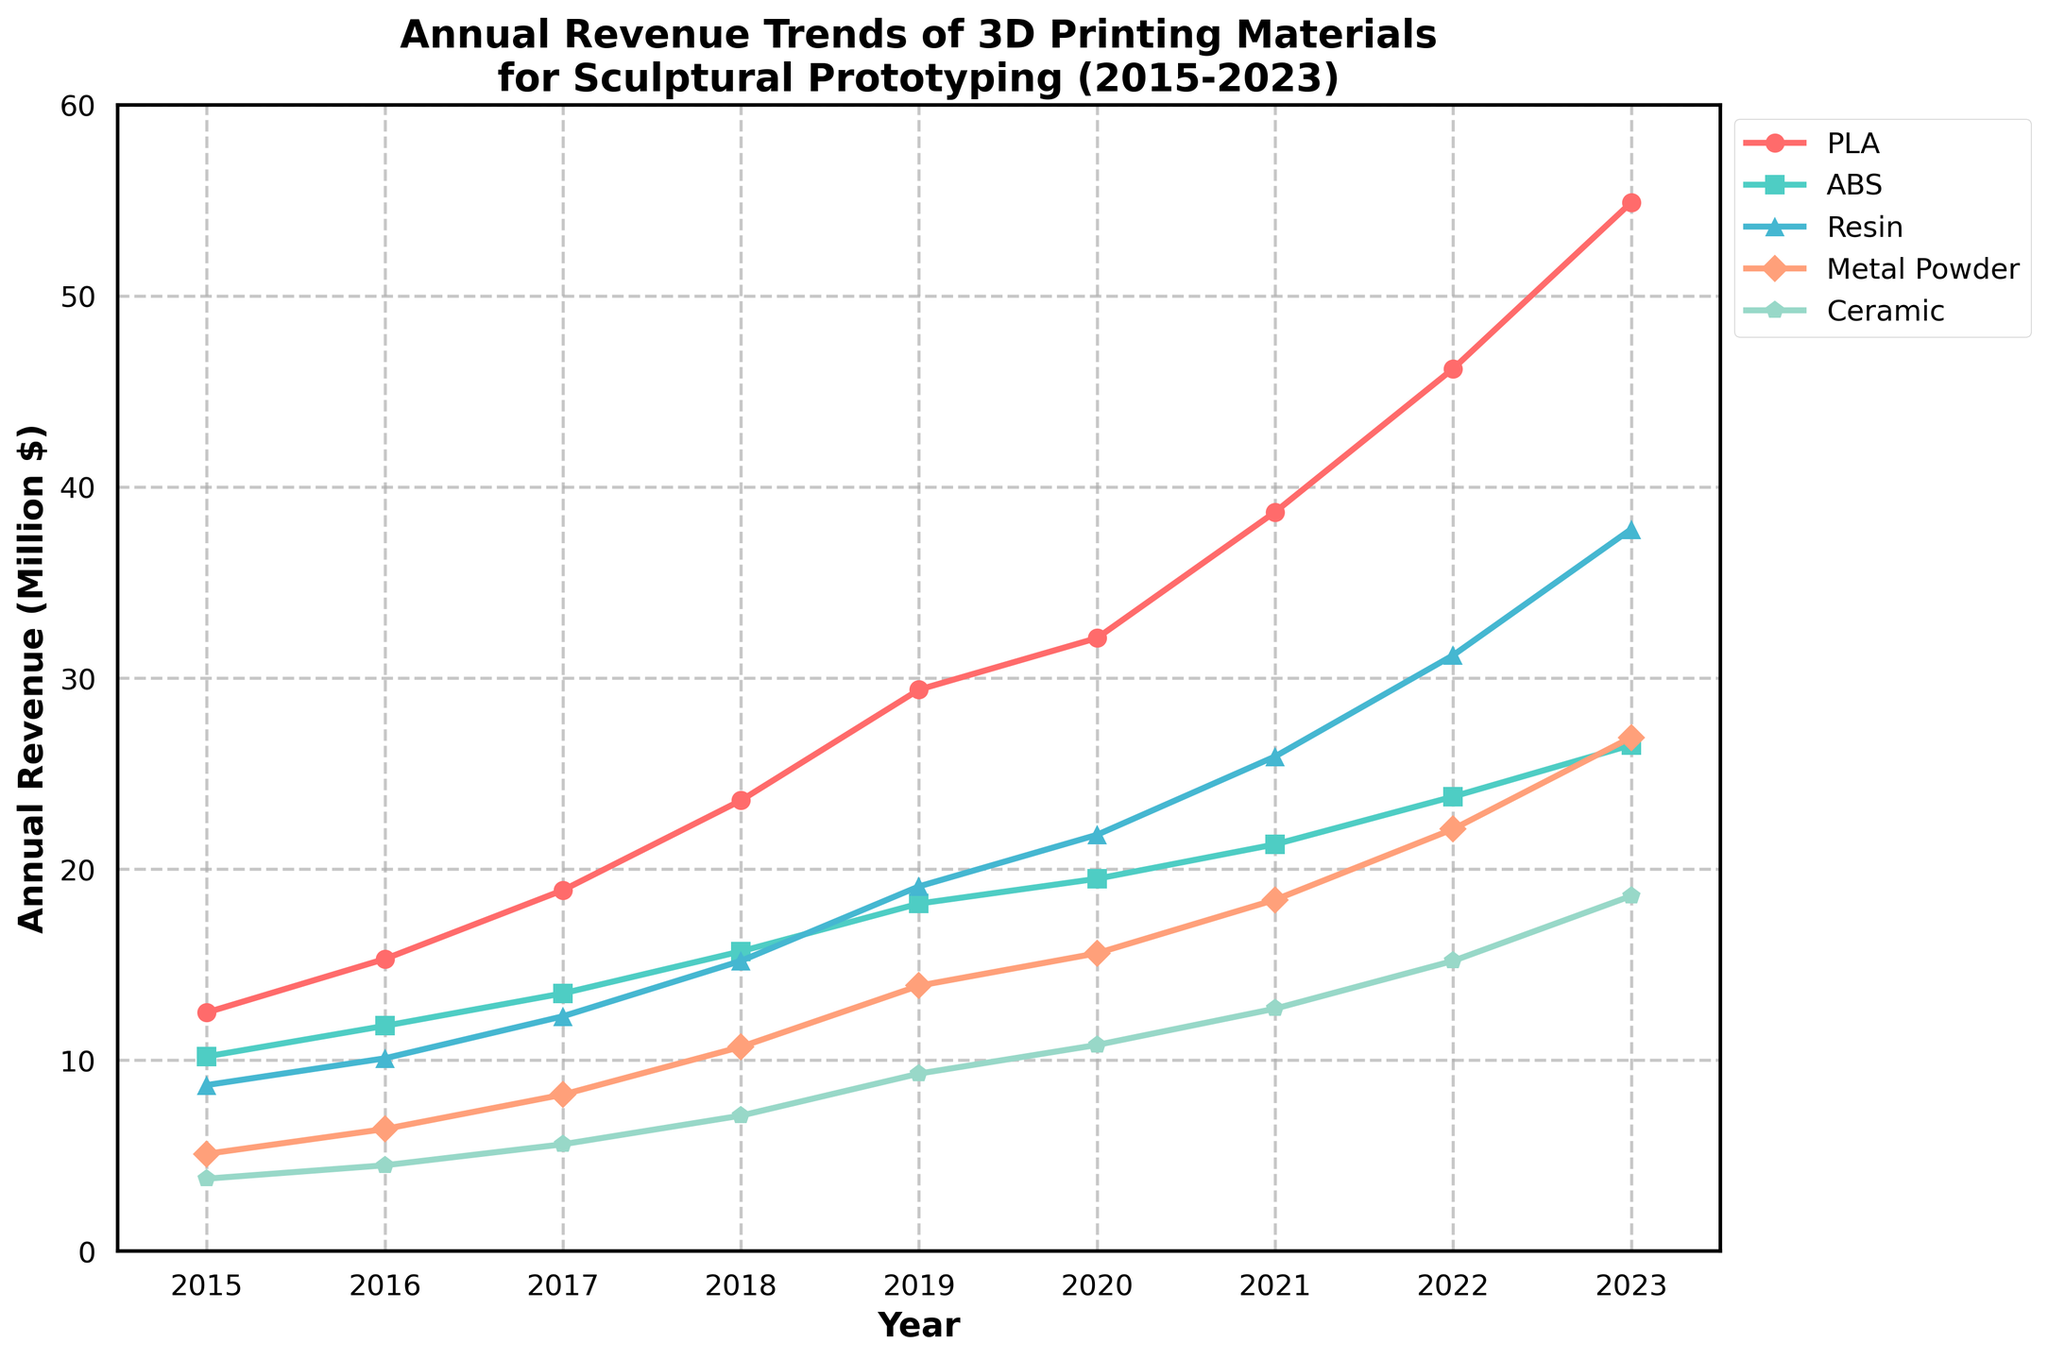What was the annual revenue for PLA in 2017? To find the annual revenue for PLA in 2017, locate the line representing PLA on the chart and find where it intersects with the 2017 mark on the horizontal axis.
Answer: 18.9 million $ Which material had the highest annual revenue in 2023? To determine which material had the highest annual revenue in 2023, compare the endpoints of all the lines at the 2023 mark on the horizontal axis. PLA has the highest endpoint.
Answer: PLA What is the trend for Ceramic from 2015 to 2023? To infer the trend for Ceramic, follow the Ceramic line from 2015 to 2023. The line shows an upward trend, indicating an increase over the years.
Answer: Upward trend How did the revenue of Metal Powder in 2020 compare to its revenue in 2018? To compare the revenue of Metal Powder in 2020 and 2018, locate the respective data points on the Metal Powder line. The revenue in 2020 (15.6 million $) is higher than in 2018 (10.7 million $).
Answer: Higher in 2020 What is the average annual revenue of ABS from 2015 to 2023? (rounded to one decimal) To find the average annual revenue of ABS, sum the data points from 2015 to 2023 and divide by the number of years. (10.2 + 11.8 + 13.5 + 15.7 + 18.2 + 19.5 + 21.3 + 23.8 + 26.5)/9 = 17.8 million $
Answer: 17.8 million $ Which material experienced the most significant growth from 2015 to 2023, and what is the growth amount? To determine which material experienced the most significant growth, calculate the difference between the 2023 and 2015 values for each material. PLA has the largest increase ((54.9 - 12.5) = 42.4 million $).
Answer: PLA, 42.4 million $ Did Resin surpass the annual revenue of ABS in any year between 2015 and 2023? To check if Resin surpassed ABS, compare the data points for each year between 2015 and 2023. Resin surpassed ABS from 2020 onwards.
Answer: Yes, from 2020 onwards Which material had the least revenue growth from 2015 to 2023? To find the material with the least revenue growth, calculate the difference between the 2023 and 2015 values for each material. Ceramic has the smallest change (18.6 - 3.8 = 14.8 million $).
Answer: Ceramic What can you infer about the trends of PLA and ABS in comparison from 2015 to 2023? To compare PLA and ABS trends, observe their lines from 2015 to 2023. Both show an upward trend, but PLA has a steeper slope, indicating faster growth than ABS.
Answer: PLA has a steeper upward trend than ABS How does the total annual revenue of all materials in 2023 compare to the total in 2015? To find the total annual revenue of all materials, sum their revenues for the respective years. 2023 total: 54.9 + 26.5 + 37.8 + 26.9 + 18.6 = 164.7 million $. 2015 total: 12.5 + 10.2 + 8.7 + 5.1 + 3.8 = 40.3 million $.
Answer: 2023 is significantly higher than 2015 